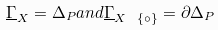<formula> <loc_0><loc_0><loc_500><loc_500>\underline { \Gamma } _ { X } = \Delta _ { P } a n d \underline { \Gamma } _ { X \ \{ \circ \} } = \partial \Delta _ { P }</formula> 